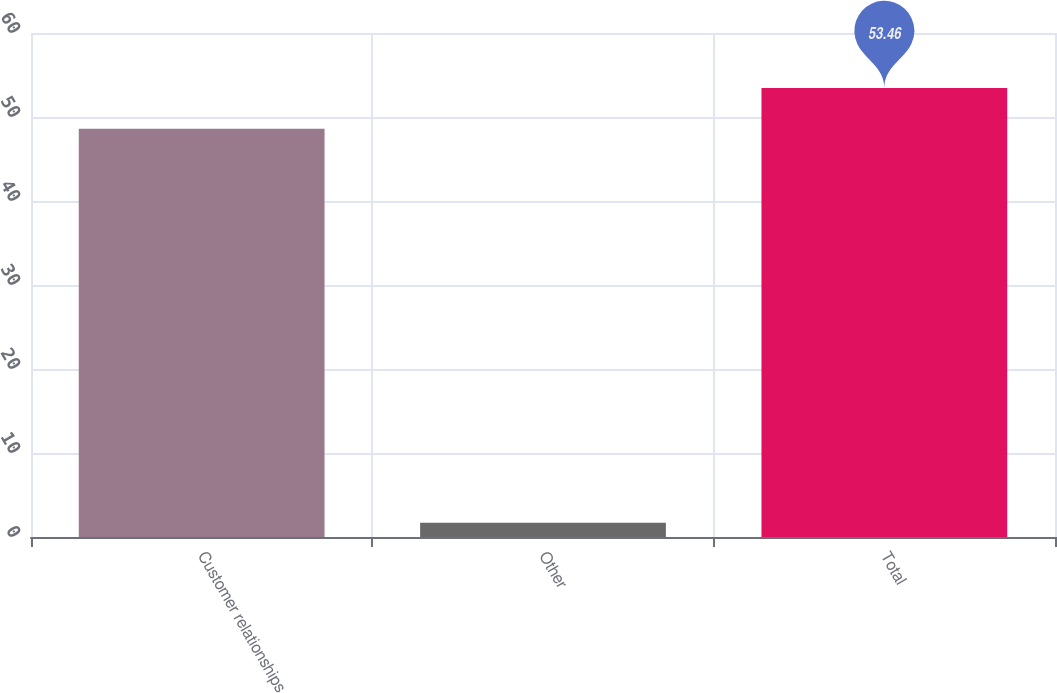Convert chart to OTSL. <chart><loc_0><loc_0><loc_500><loc_500><bar_chart><fcel>Customer relationships<fcel>Other<fcel>Total<nl><fcel>48.6<fcel>1.7<fcel>53.46<nl></chart> 